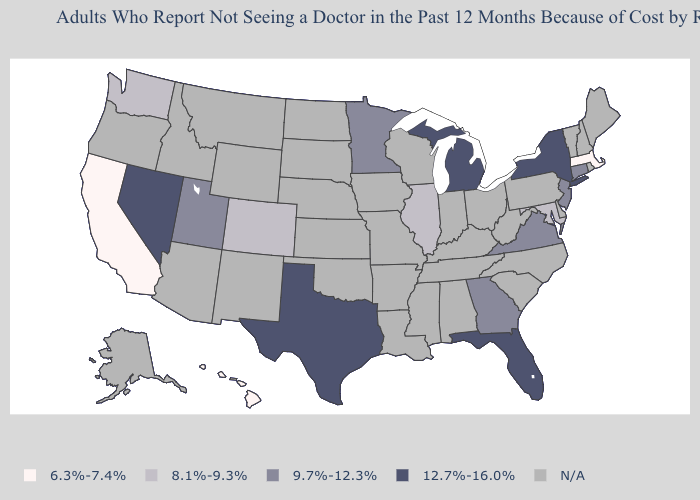Does Georgia have the lowest value in the South?
Keep it brief. No. What is the value of Maine?
Answer briefly. N/A. Name the states that have a value in the range 12.7%-16.0%?
Quick response, please. Florida, Michigan, Nevada, New York, Texas. What is the highest value in states that border Oklahoma?
Concise answer only. 12.7%-16.0%. Which states have the highest value in the USA?
Keep it brief. Florida, Michigan, Nevada, New York, Texas. What is the value of Alaska?
Be succinct. N/A. Is the legend a continuous bar?
Write a very short answer. No. What is the lowest value in the MidWest?
Quick response, please. 8.1%-9.3%. What is the value of Maine?
Be succinct. N/A. What is the lowest value in states that border Vermont?
Short answer required. 6.3%-7.4%. Name the states that have a value in the range 8.1%-9.3%?
Give a very brief answer. Colorado, Illinois, Maryland, Washington. 